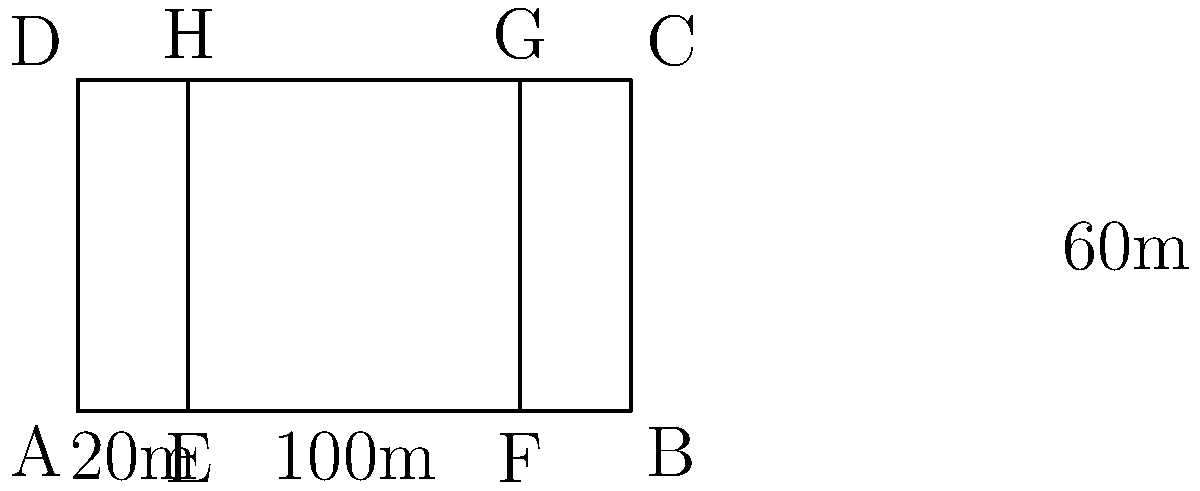The Campbelltown Stadium, home ground of the Western Suburbs Magpies, has a playing field with dimensions as shown in the diagram. The outer rectangle represents the entire field, while the inner rectangle represents the in-goal areas. If the width of each in-goal area is 20m, calculate the perimeter of the actual playing area (excluding the in-goal areas). Let's approach this step-by-step:

1) First, we need to identify the dimensions of the actual playing area:
   - The total length of the field is 100m
   - The width of each in-goal area is 20m
   - So, the length of the actual playing area is: $100m - (2 \times 20m) = 60m$
   - The width of the field remains 60m

2) Now we have a rectangle with:
   - Length = 60m
   - Width = 60m

3) To calculate the perimeter, we use the formula:
   $P = 2l + 2w$
   Where $P$ is the perimeter, $l$ is the length, and $w$ is the width

4) Substituting our values:
   $P = 2(60m) + 2(60m)$
   $P = 120m + 120m$
   $P = 240m$

Therefore, the perimeter of the actual playing area is 240m.
Answer: 240m 